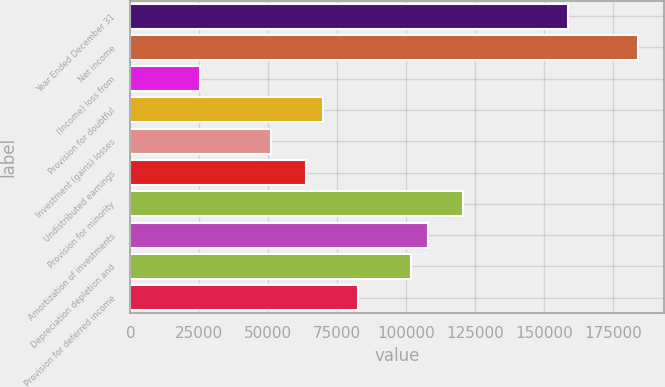Convert chart. <chart><loc_0><loc_0><loc_500><loc_500><bar_chart><fcel>Year Ended December 31<fcel>Net income<fcel>(Income) loss from<fcel>Provision for doubtful<fcel>Investment (gains) losses<fcel>Undistributed earnings<fcel>Provision for minority<fcel>Amortization of investments<fcel>Depreciation depletion and<fcel>Provision for deferred income<nl><fcel>158790<fcel>184196<fcel>25408<fcel>69868.5<fcel>50814<fcel>63517<fcel>120680<fcel>107978<fcel>101626<fcel>82571.5<nl></chart> 